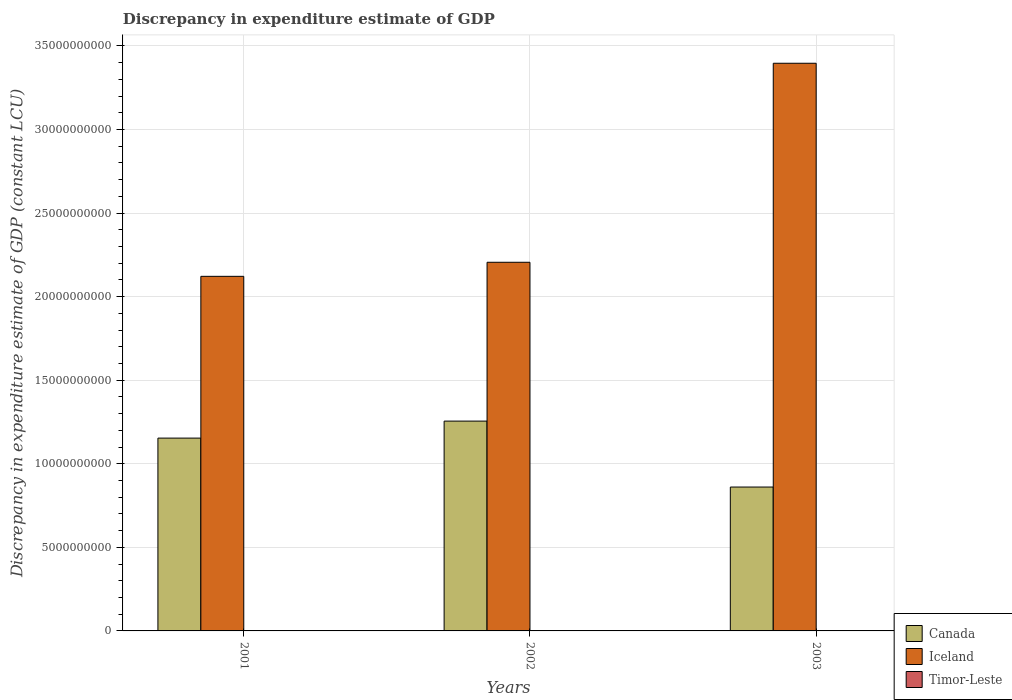How many different coloured bars are there?
Provide a short and direct response. 3. How many bars are there on the 1st tick from the left?
Offer a terse response. 3. In how many cases, is the number of bars for a given year not equal to the number of legend labels?
Ensure brevity in your answer.  2. What is the discrepancy in expenditure estimate of GDP in Iceland in 2001?
Offer a very short reply. 2.12e+1. Across all years, what is the maximum discrepancy in expenditure estimate of GDP in Timor-Leste?
Ensure brevity in your answer.  1.90e+07. Across all years, what is the minimum discrepancy in expenditure estimate of GDP in Iceland?
Keep it short and to the point. 2.12e+1. In which year was the discrepancy in expenditure estimate of GDP in Iceland maximum?
Keep it short and to the point. 2003. What is the total discrepancy in expenditure estimate of GDP in Timor-Leste in the graph?
Keep it short and to the point. 1.90e+07. What is the difference between the discrepancy in expenditure estimate of GDP in Iceland in 2001 and that in 2002?
Your answer should be compact. -8.42e+08. What is the difference between the discrepancy in expenditure estimate of GDP in Timor-Leste in 2001 and the discrepancy in expenditure estimate of GDP in Canada in 2002?
Provide a short and direct response. -1.25e+1. What is the average discrepancy in expenditure estimate of GDP in Iceland per year?
Keep it short and to the point. 2.57e+1. In the year 2002, what is the difference between the discrepancy in expenditure estimate of GDP in Canada and discrepancy in expenditure estimate of GDP in Iceland?
Ensure brevity in your answer.  -9.50e+09. In how many years, is the discrepancy in expenditure estimate of GDP in Canada greater than 4000000000 LCU?
Make the answer very short. 3. What is the ratio of the discrepancy in expenditure estimate of GDP in Canada in 2001 to that in 2003?
Your answer should be compact. 1.34. What is the difference between the highest and the second highest discrepancy in expenditure estimate of GDP in Iceland?
Keep it short and to the point. 1.19e+1. What is the difference between the highest and the lowest discrepancy in expenditure estimate of GDP in Iceland?
Offer a very short reply. 1.27e+1. How many years are there in the graph?
Ensure brevity in your answer.  3. Are the values on the major ticks of Y-axis written in scientific E-notation?
Give a very brief answer. No. Does the graph contain grids?
Provide a succinct answer. Yes. How are the legend labels stacked?
Your answer should be compact. Vertical. What is the title of the graph?
Your answer should be very brief. Discrepancy in expenditure estimate of GDP. Does "Trinidad and Tobago" appear as one of the legend labels in the graph?
Make the answer very short. No. What is the label or title of the X-axis?
Your answer should be very brief. Years. What is the label or title of the Y-axis?
Provide a succinct answer. Discrepancy in expenditure estimate of GDP (constant LCU). What is the Discrepancy in expenditure estimate of GDP (constant LCU) of Canada in 2001?
Ensure brevity in your answer.  1.15e+1. What is the Discrepancy in expenditure estimate of GDP (constant LCU) of Iceland in 2001?
Make the answer very short. 2.12e+1. What is the Discrepancy in expenditure estimate of GDP (constant LCU) of Timor-Leste in 2001?
Your answer should be very brief. 1.90e+07. What is the Discrepancy in expenditure estimate of GDP (constant LCU) of Canada in 2002?
Make the answer very short. 1.26e+1. What is the Discrepancy in expenditure estimate of GDP (constant LCU) in Iceland in 2002?
Provide a succinct answer. 2.21e+1. What is the Discrepancy in expenditure estimate of GDP (constant LCU) of Timor-Leste in 2002?
Offer a terse response. 0. What is the Discrepancy in expenditure estimate of GDP (constant LCU) in Canada in 2003?
Provide a short and direct response. 8.61e+09. What is the Discrepancy in expenditure estimate of GDP (constant LCU) in Iceland in 2003?
Your answer should be very brief. 3.40e+1. Across all years, what is the maximum Discrepancy in expenditure estimate of GDP (constant LCU) in Canada?
Your answer should be very brief. 1.26e+1. Across all years, what is the maximum Discrepancy in expenditure estimate of GDP (constant LCU) of Iceland?
Provide a succinct answer. 3.40e+1. Across all years, what is the maximum Discrepancy in expenditure estimate of GDP (constant LCU) of Timor-Leste?
Provide a short and direct response. 1.90e+07. Across all years, what is the minimum Discrepancy in expenditure estimate of GDP (constant LCU) of Canada?
Your answer should be very brief. 8.61e+09. Across all years, what is the minimum Discrepancy in expenditure estimate of GDP (constant LCU) in Iceland?
Your answer should be very brief. 2.12e+1. Across all years, what is the minimum Discrepancy in expenditure estimate of GDP (constant LCU) in Timor-Leste?
Keep it short and to the point. 0. What is the total Discrepancy in expenditure estimate of GDP (constant LCU) in Canada in the graph?
Your response must be concise. 3.27e+1. What is the total Discrepancy in expenditure estimate of GDP (constant LCU) of Iceland in the graph?
Offer a terse response. 7.72e+1. What is the total Discrepancy in expenditure estimate of GDP (constant LCU) in Timor-Leste in the graph?
Your response must be concise. 1.90e+07. What is the difference between the Discrepancy in expenditure estimate of GDP (constant LCU) in Canada in 2001 and that in 2002?
Your answer should be very brief. -1.02e+09. What is the difference between the Discrepancy in expenditure estimate of GDP (constant LCU) of Iceland in 2001 and that in 2002?
Ensure brevity in your answer.  -8.42e+08. What is the difference between the Discrepancy in expenditure estimate of GDP (constant LCU) of Canada in 2001 and that in 2003?
Your answer should be compact. 2.93e+09. What is the difference between the Discrepancy in expenditure estimate of GDP (constant LCU) of Iceland in 2001 and that in 2003?
Offer a terse response. -1.27e+1. What is the difference between the Discrepancy in expenditure estimate of GDP (constant LCU) of Canada in 2002 and that in 2003?
Give a very brief answer. 3.94e+09. What is the difference between the Discrepancy in expenditure estimate of GDP (constant LCU) of Iceland in 2002 and that in 2003?
Give a very brief answer. -1.19e+1. What is the difference between the Discrepancy in expenditure estimate of GDP (constant LCU) in Canada in 2001 and the Discrepancy in expenditure estimate of GDP (constant LCU) in Iceland in 2002?
Keep it short and to the point. -1.05e+1. What is the difference between the Discrepancy in expenditure estimate of GDP (constant LCU) in Canada in 2001 and the Discrepancy in expenditure estimate of GDP (constant LCU) in Iceland in 2003?
Offer a terse response. -2.24e+1. What is the difference between the Discrepancy in expenditure estimate of GDP (constant LCU) in Canada in 2002 and the Discrepancy in expenditure estimate of GDP (constant LCU) in Iceland in 2003?
Give a very brief answer. -2.14e+1. What is the average Discrepancy in expenditure estimate of GDP (constant LCU) in Canada per year?
Your response must be concise. 1.09e+1. What is the average Discrepancy in expenditure estimate of GDP (constant LCU) of Iceland per year?
Make the answer very short. 2.57e+1. What is the average Discrepancy in expenditure estimate of GDP (constant LCU) in Timor-Leste per year?
Provide a succinct answer. 6.32e+06. In the year 2001, what is the difference between the Discrepancy in expenditure estimate of GDP (constant LCU) of Canada and Discrepancy in expenditure estimate of GDP (constant LCU) of Iceland?
Your response must be concise. -9.68e+09. In the year 2001, what is the difference between the Discrepancy in expenditure estimate of GDP (constant LCU) in Canada and Discrepancy in expenditure estimate of GDP (constant LCU) in Timor-Leste?
Your response must be concise. 1.15e+1. In the year 2001, what is the difference between the Discrepancy in expenditure estimate of GDP (constant LCU) of Iceland and Discrepancy in expenditure estimate of GDP (constant LCU) of Timor-Leste?
Ensure brevity in your answer.  2.12e+1. In the year 2002, what is the difference between the Discrepancy in expenditure estimate of GDP (constant LCU) of Canada and Discrepancy in expenditure estimate of GDP (constant LCU) of Iceland?
Offer a terse response. -9.50e+09. In the year 2003, what is the difference between the Discrepancy in expenditure estimate of GDP (constant LCU) of Canada and Discrepancy in expenditure estimate of GDP (constant LCU) of Iceland?
Offer a very short reply. -2.54e+1. What is the ratio of the Discrepancy in expenditure estimate of GDP (constant LCU) of Canada in 2001 to that in 2002?
Offer a very short reply. 0.92. What is the ratio of the Discrepancy in expenditure estimate of GDP (constant LCU) of Iceland in 2001 to that in 2002?
Your response must be concise. 0.96. What is the ratio of the Discrepancy in expenditure estimate of GDP (constant LCU) of Canada in 2001 to that in 2003?
Provide a succinct answer. 1.34. What is the ratio of the Discrepancy in expenditure estimate of GDP (constant LCU) of Iceland in 2001 to that in 2003?
Provide a short and direct response. 0.62. What is the ratio of the Discrepancy in expenditure estimate of GDP (constant LCU) in Canada in 2002 to that in 2003?
Give a very brief answer. 1.46. What is the ratio of the Discrepancy in expenditure estimate of GDP (constant LCU) in Iceland in 2002 to that in 2003?
Offer a very short reply. 0.65. What is the difference between the highest and the second highest Discrepancy in expenditure estimate of GDP (constant LCU) in Canada?
Ensure brevity in your answer.  1.02e+09. What is the difference between the highest and the second highest Discrepancy in expenditure estimate of GDP (constant LCU) in Iceland?
Offer a very short reply. 1.19e+1. What is the difference between the highest and the lowest Discrepancy in expenditure estimate of GDP (constant LCU) in Canada?
Give a very brief answer. 3.94e+09. What is the difference between the highest and the lowest Discrepancy in expenditure estimate of GDP (constant LCU) of Iceland?
Offer a terse response. 1.27e+1. What is the difference between the highest and the lowest Discrepancy in expenditure estimate of GDP (constant LCU) of Timor-Leste?
Your response must be concise. 1.90e+07. 